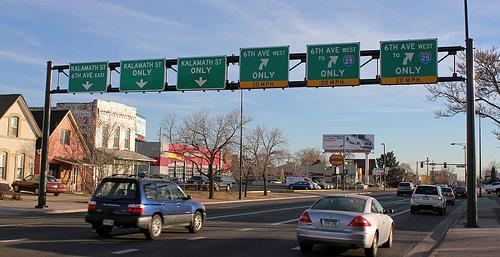What do the left lanes of the road direct towards in the image? The left lanes are for Kalamath St. Analyze the elements of the image and describe an interaction between objects. Several vehicles are driving down the road with a red traffic light, possibly indicating that they will have to stop soon or that one of them has its brake lights on. Identify the main objects present in the sky portion of the image. There are no main objects in the sky; it is blue in color. State the color and shape of the sign with a green and white background. The sign is rectangular in shape and has a green and white background. What color is the text on the sign with a green background? The text is white. Count the number of cars driving on the street. There are 6 cars driving on the street. Does the sign with the green and white background have a picture of a bicycle on it? There is no mention of a picture of a bicycle on any sign in the image. Is the house that is painted blue on the right side of the image? The house in the image is painted red, not blue. Are there pink flowers on the tree with no leaves? The tree is described as having no leaves, and there is no mention of flowers, pink or otherwise. Is the sky in the image purple with clouds? The sky is described as blue in color, not purple. It also doesn't mention any clouds. Is the car driving near the street blue and white? The mentioned car driving on the street has no combination of blue and white color. Does the rectangular traffic sign near the top of the image have the colors black and orange? The rectangular traffic signs mentioned are green, white, and yellow, not black and orange. 